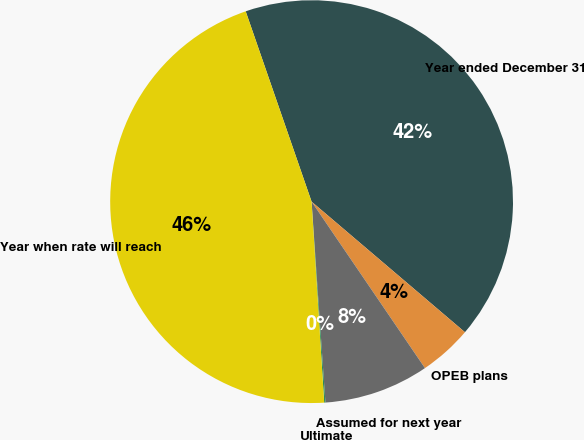<chart> <loc_0><loc_0><loc_500><loc_500><pie_chart><fcel>Year ended December 31<fcel>OPEB plans<fcel>Assumed for next year<fcel>Ultimate<fcel>Year when rate will reach<nl><fcel>41.53%<fcel>4.26%<fcel>8.42%<fcel>0.1%<fcel>45.69%<nl></chart> 